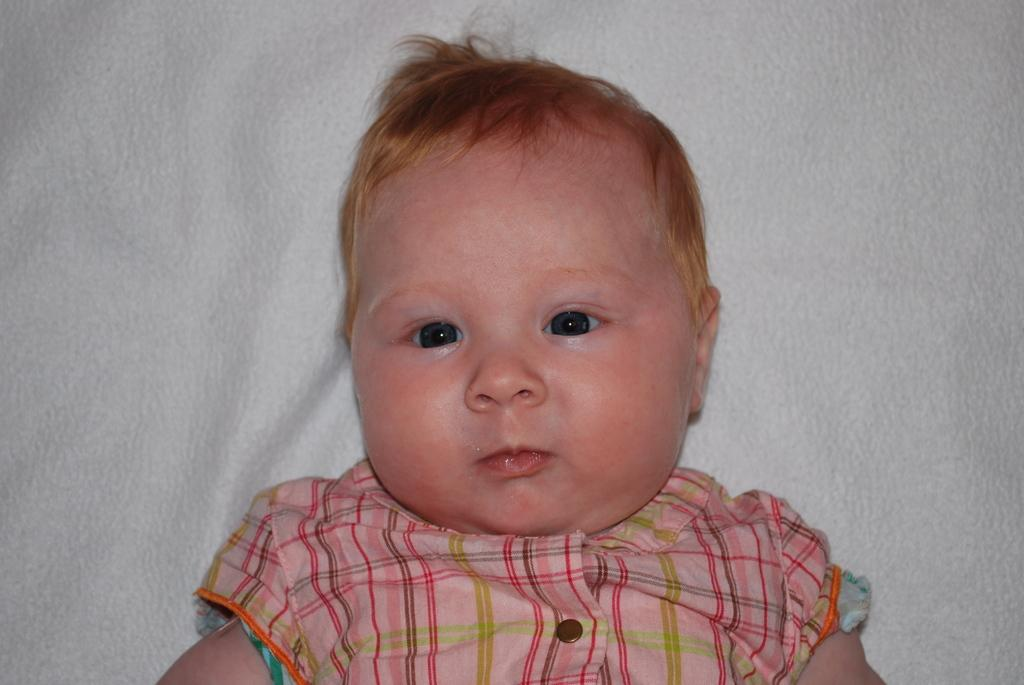What is the main subject of the image? The main subject of the image is a kid. Where is the kid located in the image? The kid is lying on a white color cloth. What type of stem can be seen growing from the crib in the image? There is no crib or stem present in the image; it only features a kid lying on a white color cloth. 